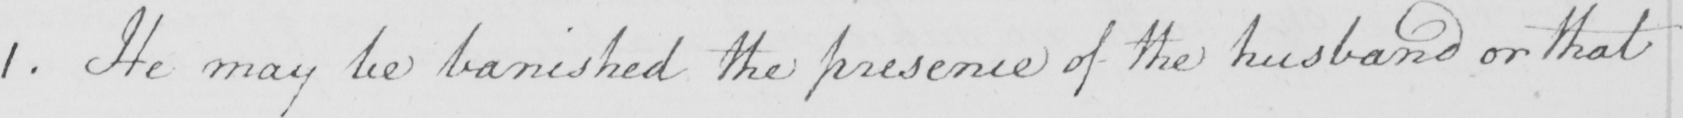Transcribe the text shown in this historical manuscript line. 1 . He may be banished the presence of the husband or that 